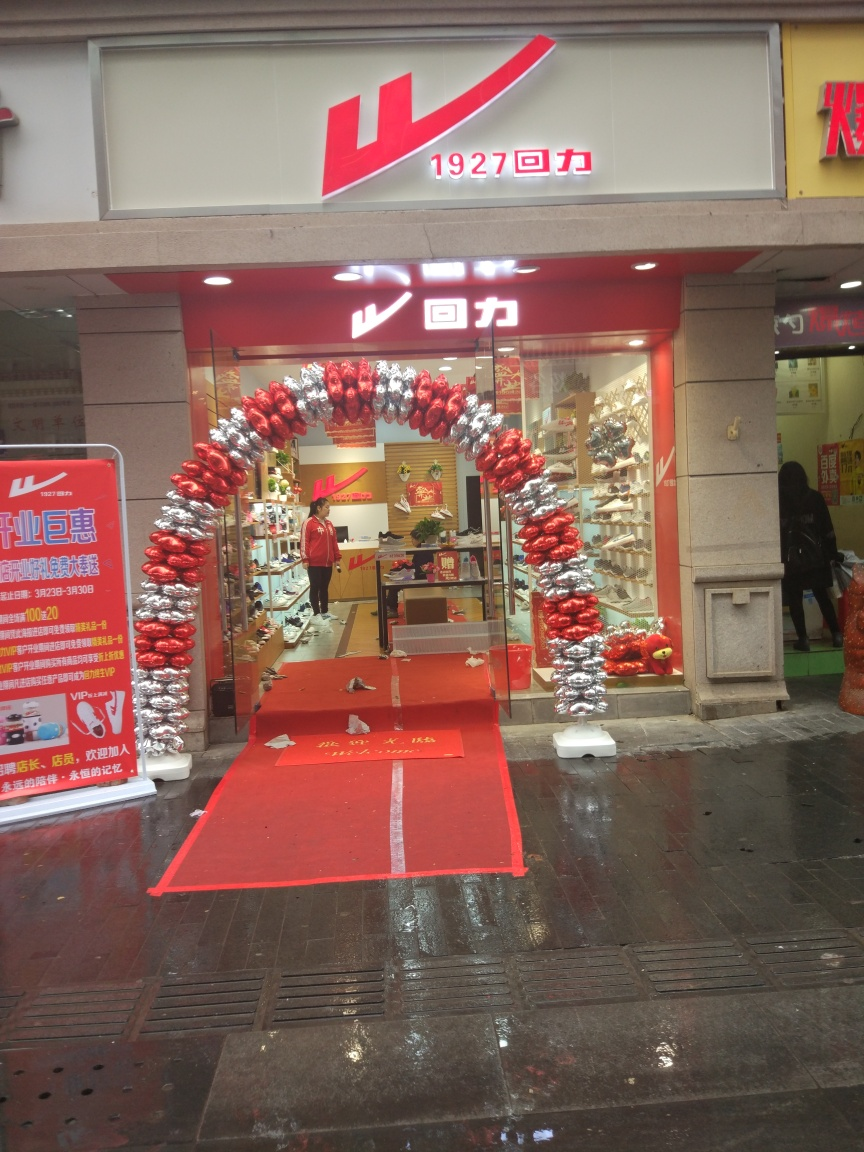What kind of store is shown in the image? The store in the image appears to be a footwear retail shop, showcasing various styles of shoes on the shelves inside. 